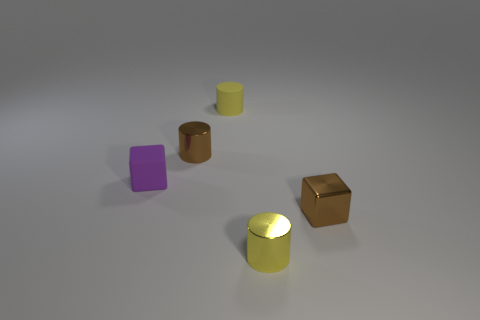Add 2 purple matte cubes. How many objects exist? 7 Subtract all cubes. How many objects are left? 3 Subtract 0 cyan cylinders. How many objects are left? 5 Subtract all yellow matte things. Subtract all small purple rubber cubes. How many objects are left? 3 Add 1 tiny purple things. How many tiny purple things are left? 2 Add 1 big green cylinders. How many big green cylinders exist? 1 